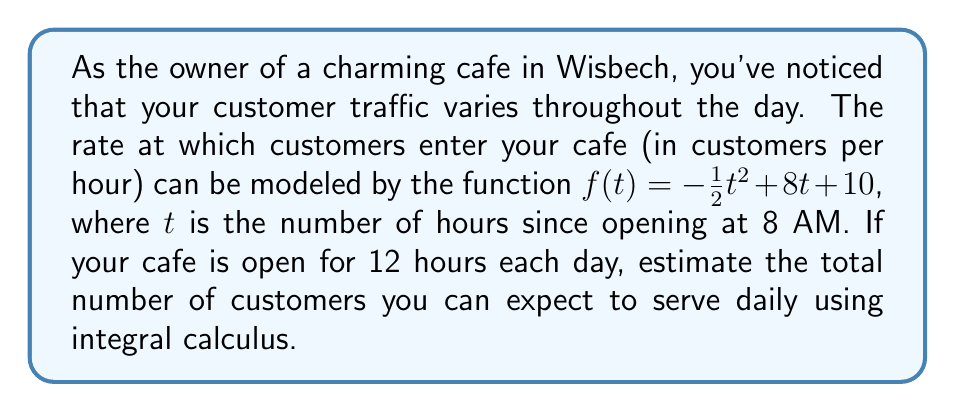Provide a solution to this math problem. To solve this problem, we need to use definite integration to calculate the area under the curve of the given function over the specified time period. This will give us the total number of customers expected throughout the day.

1) The function representing the rate of customers entering the cafe is:
   $f(t) = -\frac{1}{2}t^2 + 8t + 10$

2) We need to integrate this function from $t=0$ (opening time) to $t=12$ (closing time):

   $$\int_0^{12} (-\frac{1}{2}t^2 + 8t + 10) dt$$

3) Let's integrate each term:
   
   $$\int_0^{12} -\frac{1}{2}t^2 dt = [-\frac{1}{6}t^3]_0^{12}$$
   $$\int_0^{12} 8t dt = [4t^2]_0^{12}$$
   $$\int_0^{12} 10 dt = [10t]_0^{12}$$

4) Now, let's evaluate each term:

   $$[-\frac{1}{6}t^3]_0^{12} = -\frac{1}{6}(12^3) - (-\frac{1}{6}(0^3)) = -288$$
   $$[4t^2]_0^{12} = 4(12^2) - 4(0^2) = 576$$
   $$[10t]_0^{12} = 10(12) - 10(0) = 120$$

5) Sum up all the terms:

   $$-288 + 576 + 120 = 408$$

Therefore, the estimated number of customers you can expect to serve daily is 408.
Answer: 408 customers 